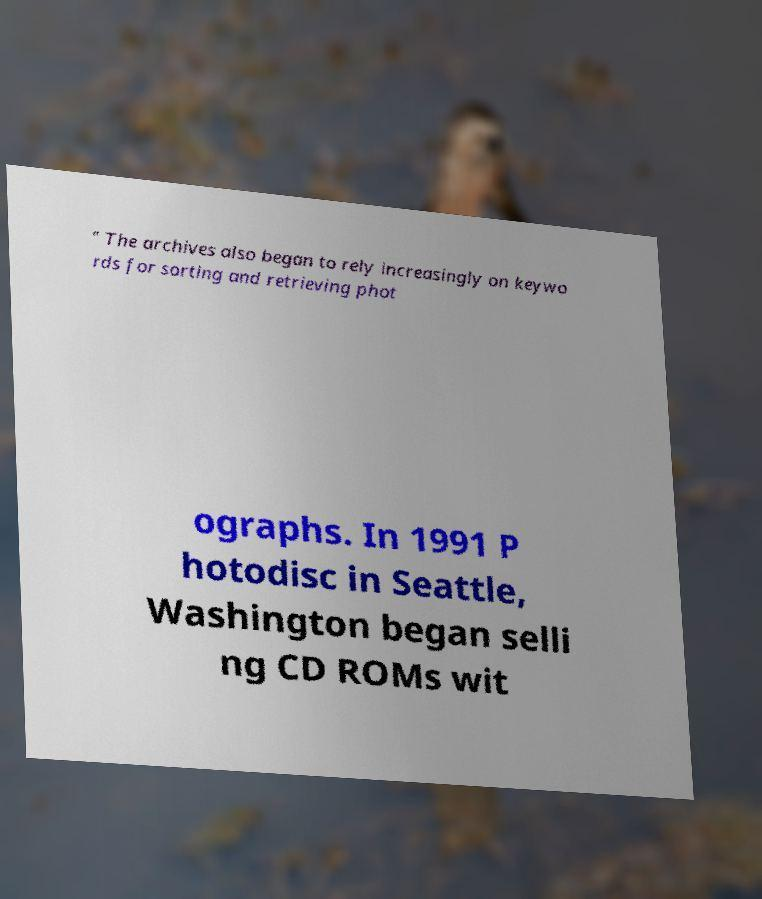Please read and relay the text visible in this image. What does it say? " The archives also began to rely increasingly on keywo rds for sorting and retrieving phot ographs. In 1991 P hotodisc in Seattle, Washington began selli ng CD ROMs wit 